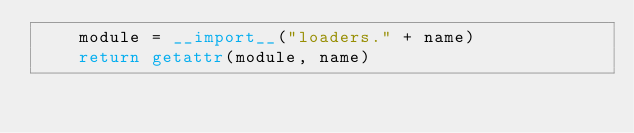<code> <loc_0><loc_0><loc_500><loc_500><_Python_>    module = __import__("loaders." + name)
    return getattr(module, name)</code> 